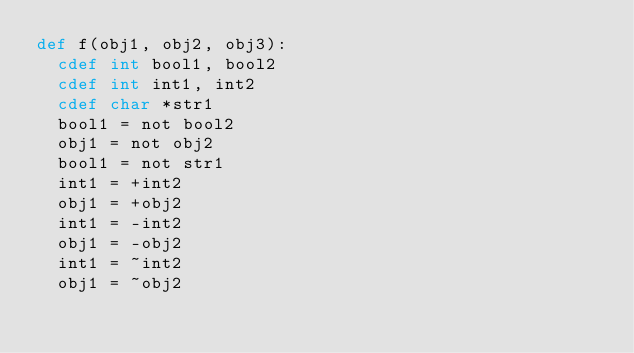Convert code to text. <code><loc_0><loc_0><loc_500><loc_500><_Cython_>def f(obj1, obj2, obj3):
	cdef int bool1, bool2
	cdef int int1, int2
	cdef char *str1
	bool1 = not bool2
	obj1 = not obj2
	bool1 = not str1
	int1 = +int2
	obj1 = +obj2
	int1 = -int2
	obj1 = -obj2
	int1 = ~int2
	obj1 = ~obj2
	</code> 